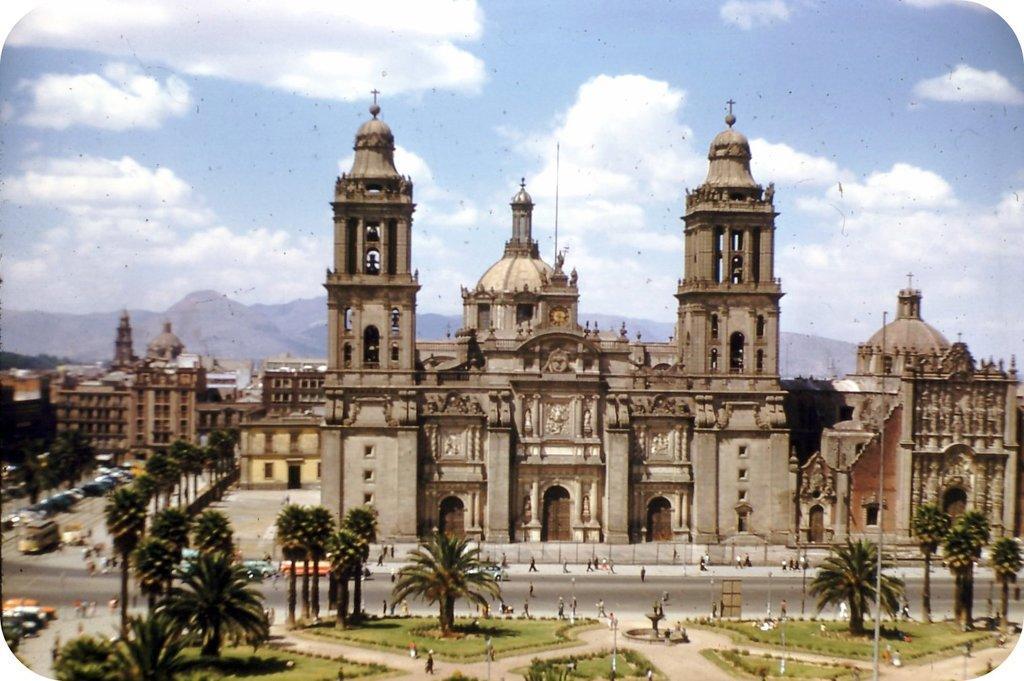In one or two sentences, can you explain what this image depicts? The picture looks like a depiction. In the ground of the picture there are trees, grass and people. In the center of the picture there are buildings, trees, people and road. In the background there are hills. At the top it is sky. 